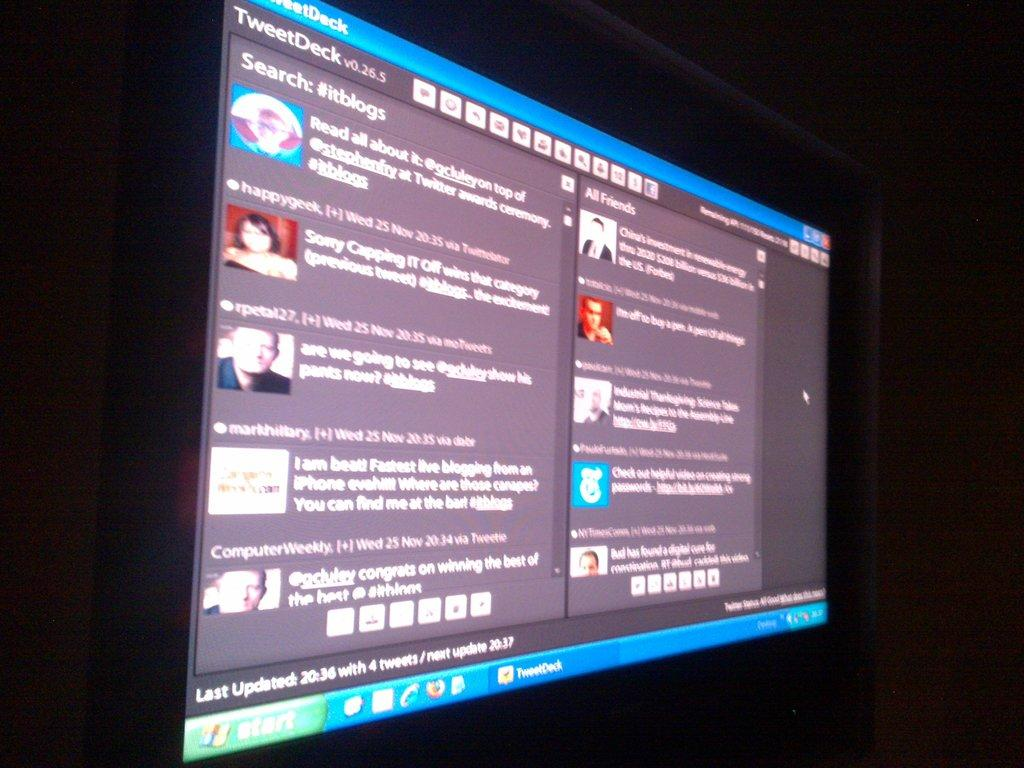<image>
Summarize the visual content of the image. A computer screen displays a program running titled TweetDeck. 